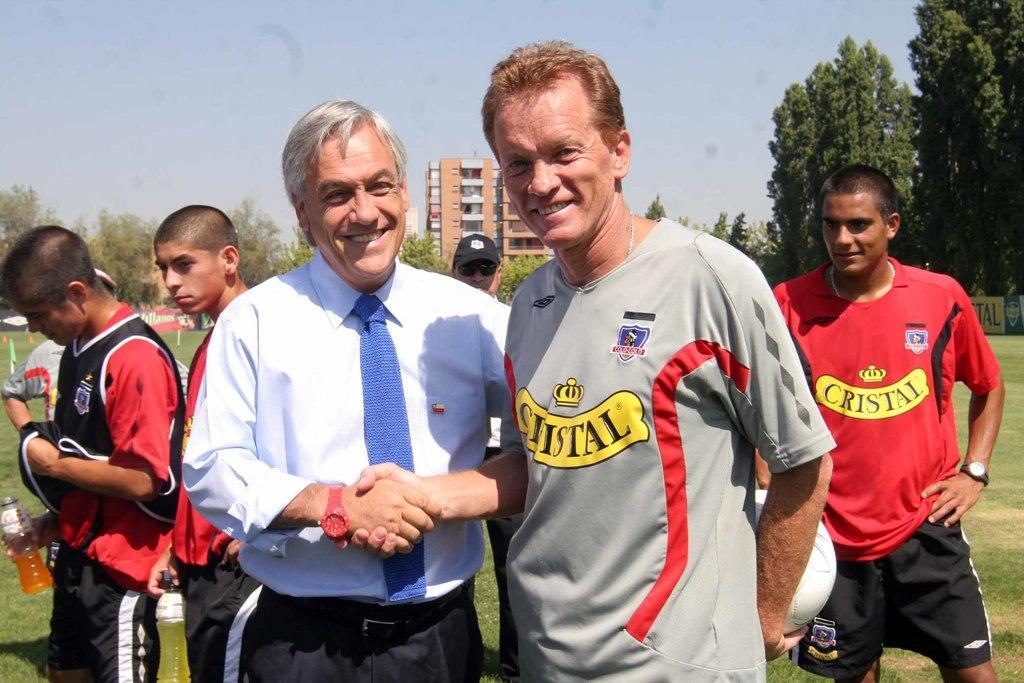Could you give a brief overview of what you see in this image? There are two persons standing and shaking each other hands and there are few people standing behind them and there are trees and buildings in the background. 